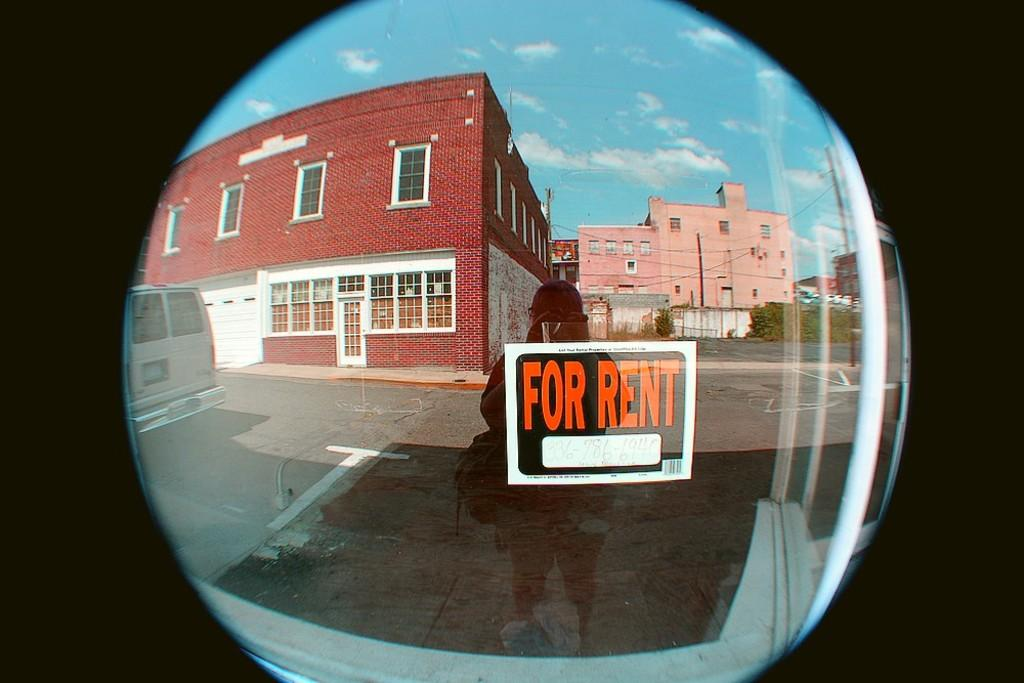Provide a one-sentence caption for the provided image. A fishbowl view of someone on a street holding a FOR RENT sign with a phone number 336-786-6940 on it. 